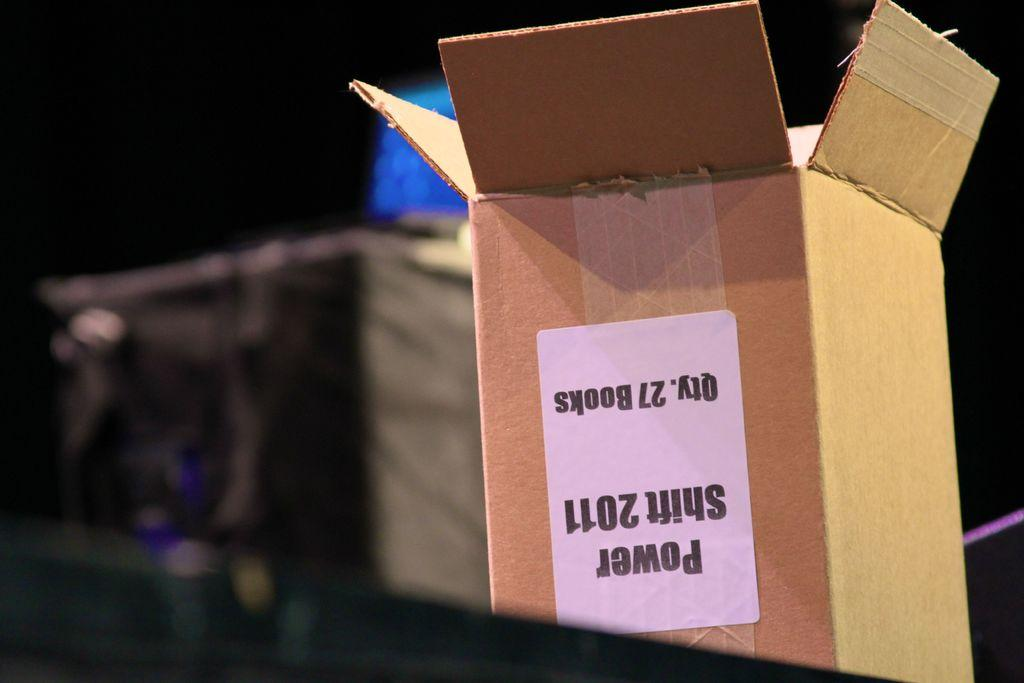<image>
Offer a succinct explanation of the picture presented. An upside down box the originally contained 27 copies of Power Shift 2011. 